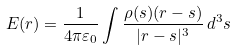<formula> <loc_0><loc_0><loc_500><loc_500>E ( r ) = { \frac { 1 } { 4 \pi \varepsilon _ { 0 } } } \int { \frac { \rho ( s ) ( r - s ) } { | r - s | ^ { 3 } } } \, d ^ { 3 } s</formula> 